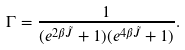Convert formula to latex. <formula><loc_0><loc_0><loc_500><loc_500>\Gamma = \frac { 1 } { ( e ^ { 2 \beta \tilde { J } } + 1 ) ( e ^ { 4 \beta \tilde { J } } + 1 ) } .</formula> 